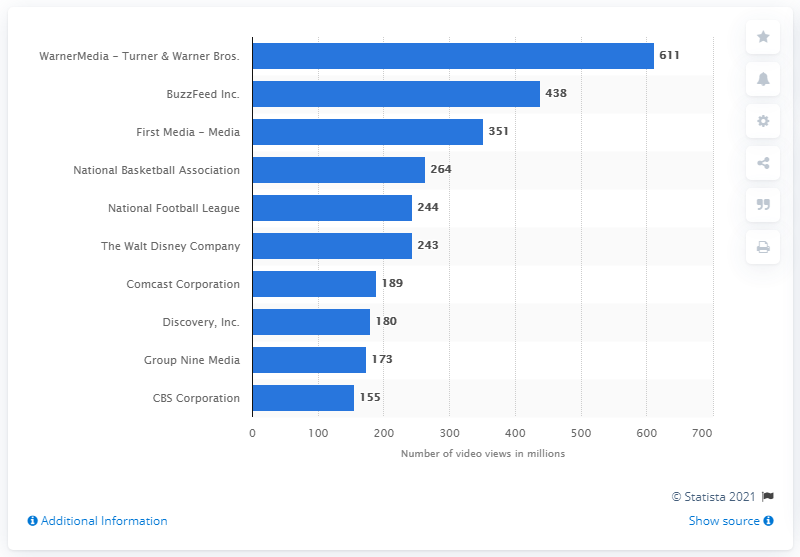List a handful of essential elements in this visual. In 2019, Warner Media-Turner and Warner Bros. had a total of 611 video views on social media. BuzzFeed received approximately 438 million video views in 2019. 